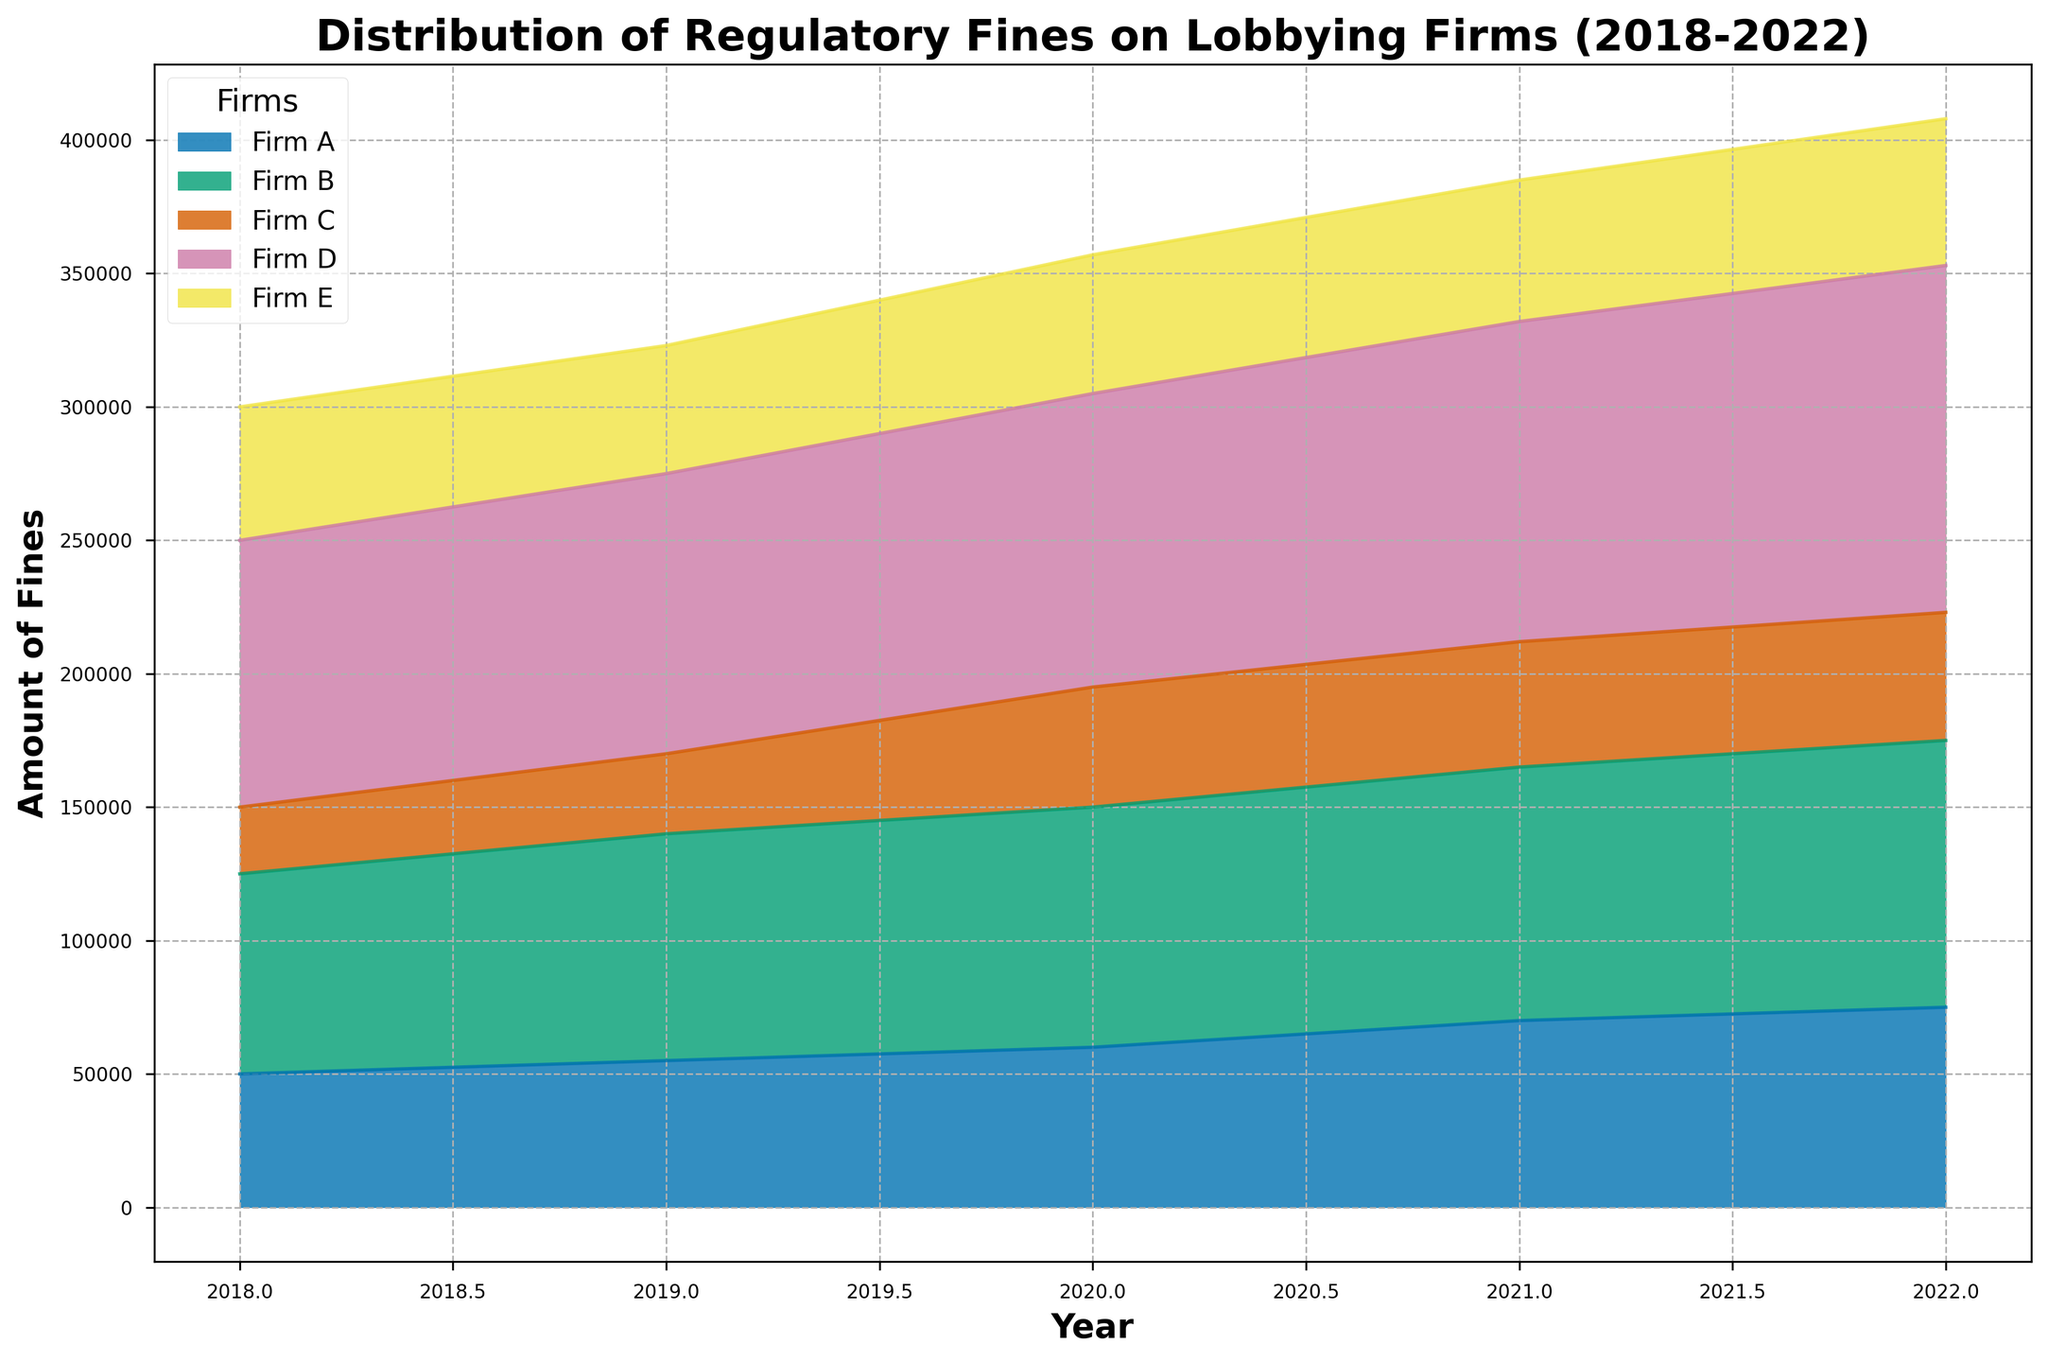What year did Firm D incur the highest fines? First, look at the area chart and identify the years and corresponding fine amounts for Firm D. It can be observed that the highest section for Firm D is in the year 2022.
Answer: 2022 Which firm had the smallest fines in 2018? Refer to the 2018 section of the chart. Identify the firm with the smallest area which represent the fines. Firm C has the smallest area.
Answer: Firm C Did the total fines for Firm A increase or decrease from 2018 to 2022? Check the amount of fines for Firm A in 2018 and compare it with the amount in 2022. Firm A's fines increased from 50,000 in 2018 to 75,000 in 2022.
Answer: Increase What is the average fine amount for Firm B over the 5-year period? Sum the fines for Firm B for each year (2018: 75,000, 2019: 85,000, 2020: 90,000, 2021: 95,000, 2022: 100,000). Total fines = 445,000. Divide this by 5 years to get the average: 445,000 / 5 = 89,000.
Answer: 89,000 Which firm had a steadily increasing trend in fines over the years? Observe the trends in the area chart for each firm from 2018 to 2022. Only Firm D shows a continuously increasing trend year over year.
Answer: Firm D Compare the fines of Firm E and Firm C in 2020. Which firm was fined more? Look at the 2020 data and compare the heights of the corresponding areas. Firm E had fines of 52,000, while Firm C had fines of 45,000. Firm E had higher fines.
Answer: Firm E By how much did the fines for Firm A increase from 2018 to 2022? Subtract the 2018 fines from the 2022 fines for Firm A: 75,000 (2022) - 50,000 (2018) = 25,000.
Answer: 25,000 Did any firm experience a decrease in fines from 2021 to 2022? If so, which one? Check each firm's fines for 2021 and 2022. Firm B had fines of 95,000 in 2021, and they increased to 100,000 in 2022. All other firms' fines either increased or stayed the same.
Answer: No firm What is the total amount of fines incurred by all firms in 2020? Sum the fines for all firms in 2020: 60,000 (A) + 90,000 (B) + 45,000 (C) + 110,000 (D) + 52,000 (E) = 357,000.
Answer: 357,000 